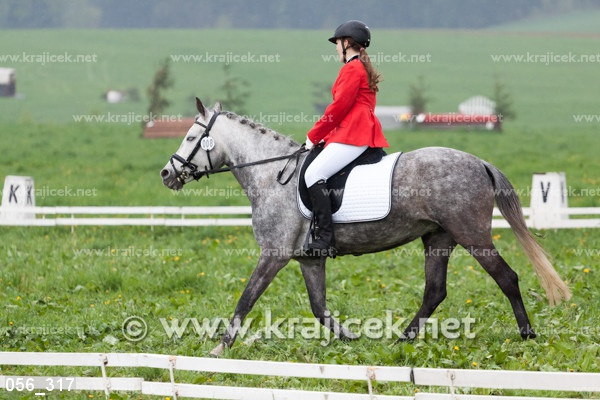Describe the objects in this image and their specific colors. I can see horse in gray, darkgray, black, and lightgray tones and people in gray, black, red, and lavender tones in this image. 